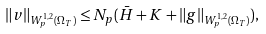<formula> <loc_0><loc_0><loc_500><loc_500>\| v \| _ { W ^ { 1 , 2 } _ { p } ( \Omega _ { T } ) } \leq N _ { p } ( \bar { H } + K + \| g \| _ { W ^ { 1 , 2 } _ { p } ( \Omega _ { T } ) } ) ,</formula> 